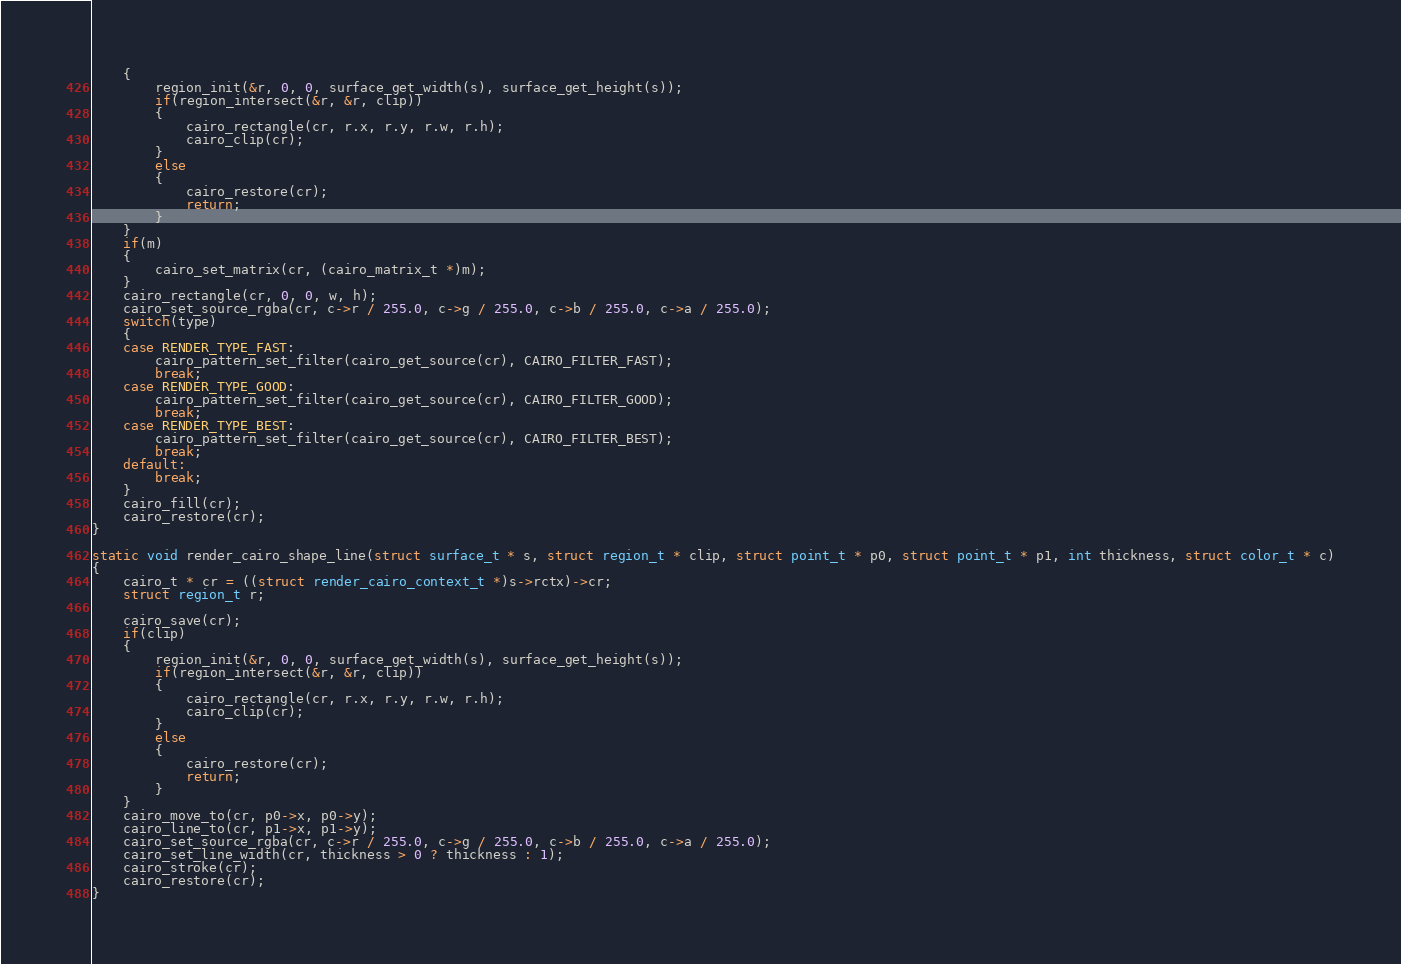Convert code to text. <code><loc_0><loc_0><loc_500><loc_500><_C_>	{
		region_init(&r, 0, 0, surface_get_width(s), surface_get_height(s));
		if(region_intersect(&r, &r, clip))
		{
			cairo_rectangle(cr, r.x, r.y, r.w, r.h);
			cairo_clip(cr);
		}
		else
		{
			cairo_restore(cr);
			return;
		}
	}
	if(m)
	{
		cairo_set_matrix(cr, (cairo_matrix_t *)m);
	}
	cairo_rectangle(cr, 0, 0, w, h);
	cairo_set_source_rgba(cr, c->r / 255.0, c->g / 255.0, c->b / 255.0, c->a / 255.0);
	switch(type)
	{
	case RENDER_TYPE_FAST:
		cairo_pattern_set_filter(cairo_get_source(cr), CAIRO_FILTER_FAST);
		break;
	case RENDER_TYPE_GOOD:
		cairo_pattern_set_filter(cairo_get_source(cr), CAIRO_FILTER_GOOD);
		break;
	case RENDER_TYPE_BEST:
		cairo_pattern_set_filter(cairo_get_source(cr), CAIRO_FILTER_BEST);
		break;
	default:
		break;
	}
	cairo_fill(cr);
	cairo_restore(cr);
}

static void render_cairo_shape_line(struct surface_t * s, struct region_t * clip, struct point_t * p0, struct point_t * p1, int thickness, struct color_t * c)
{
	cairo_t * cr = ((struct render_cairo_context_t *)s->rctx)->cr;
	struct region_t r;

	cairo_save(cr);
	if(clip)
	{
		region_init(&r, 0, 0, surface_get_width(s), surface_get_height(s));
		if(region_intersect(&r, &r, clip))
		{
			cairo_rectangle(cr, r.x, r.y, r.w, r.h);
			cairo_clip(cr);
		}
		else
		{
			cairo_restore(cr);
			return;
		}
	}
	cairo_move_to(cr, p0->x, p0->y);
	cairo_line_to(cr, p1->x, p1->y);
	cairo_set_source_rgba(cr, c->r / 255.0, c->g / 255.0, c->b / 255.0, c->a / 255.0);
	cairo_set_line_width(cr, thickness > 0 ? thickness : 1);
	cairo_stroke(cr);
	cairo_restore(cr);
}
</code> 